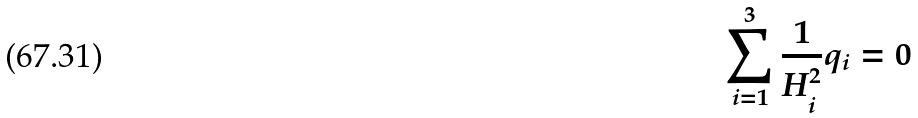<formula> <loc_0><loc_0><loc_500><loc_500>\sum _ { i = 1 } ^ { 3 } \frac { 1 } { H _ { i } ^ { 2 } } q _ { i } = 0</formula> 